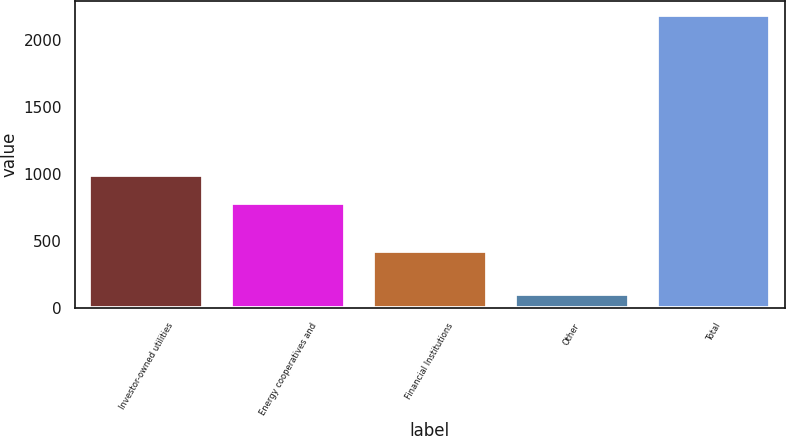<chart> <loc_0><loc_0><loc_500><loc_500><bar_chart><fcel>Investor-owned utilities<fcel>Energy cooperatives and<fcel>Financial Institutions<fcel>Other<fcel>Total<nl><fcel>993.3<fcel>786<fcel>422<fcel>108<fcel>2181<nl></chart> 